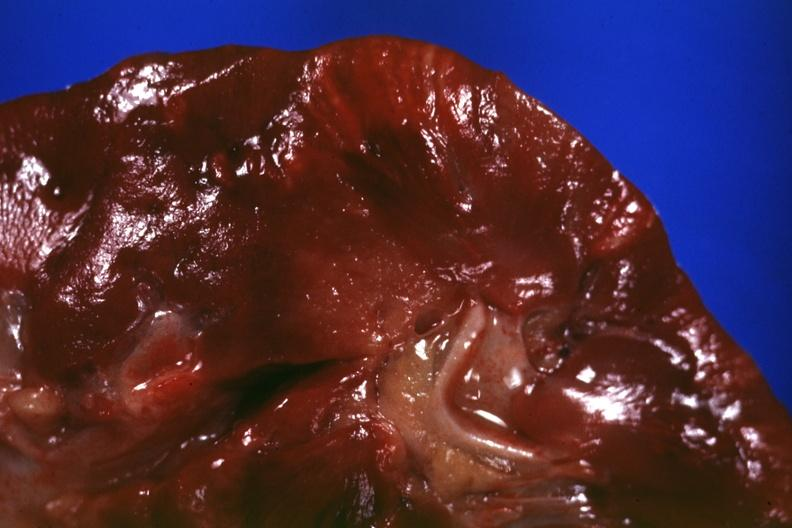s pinworm present?
Answer the question using a single word or phrase. No 